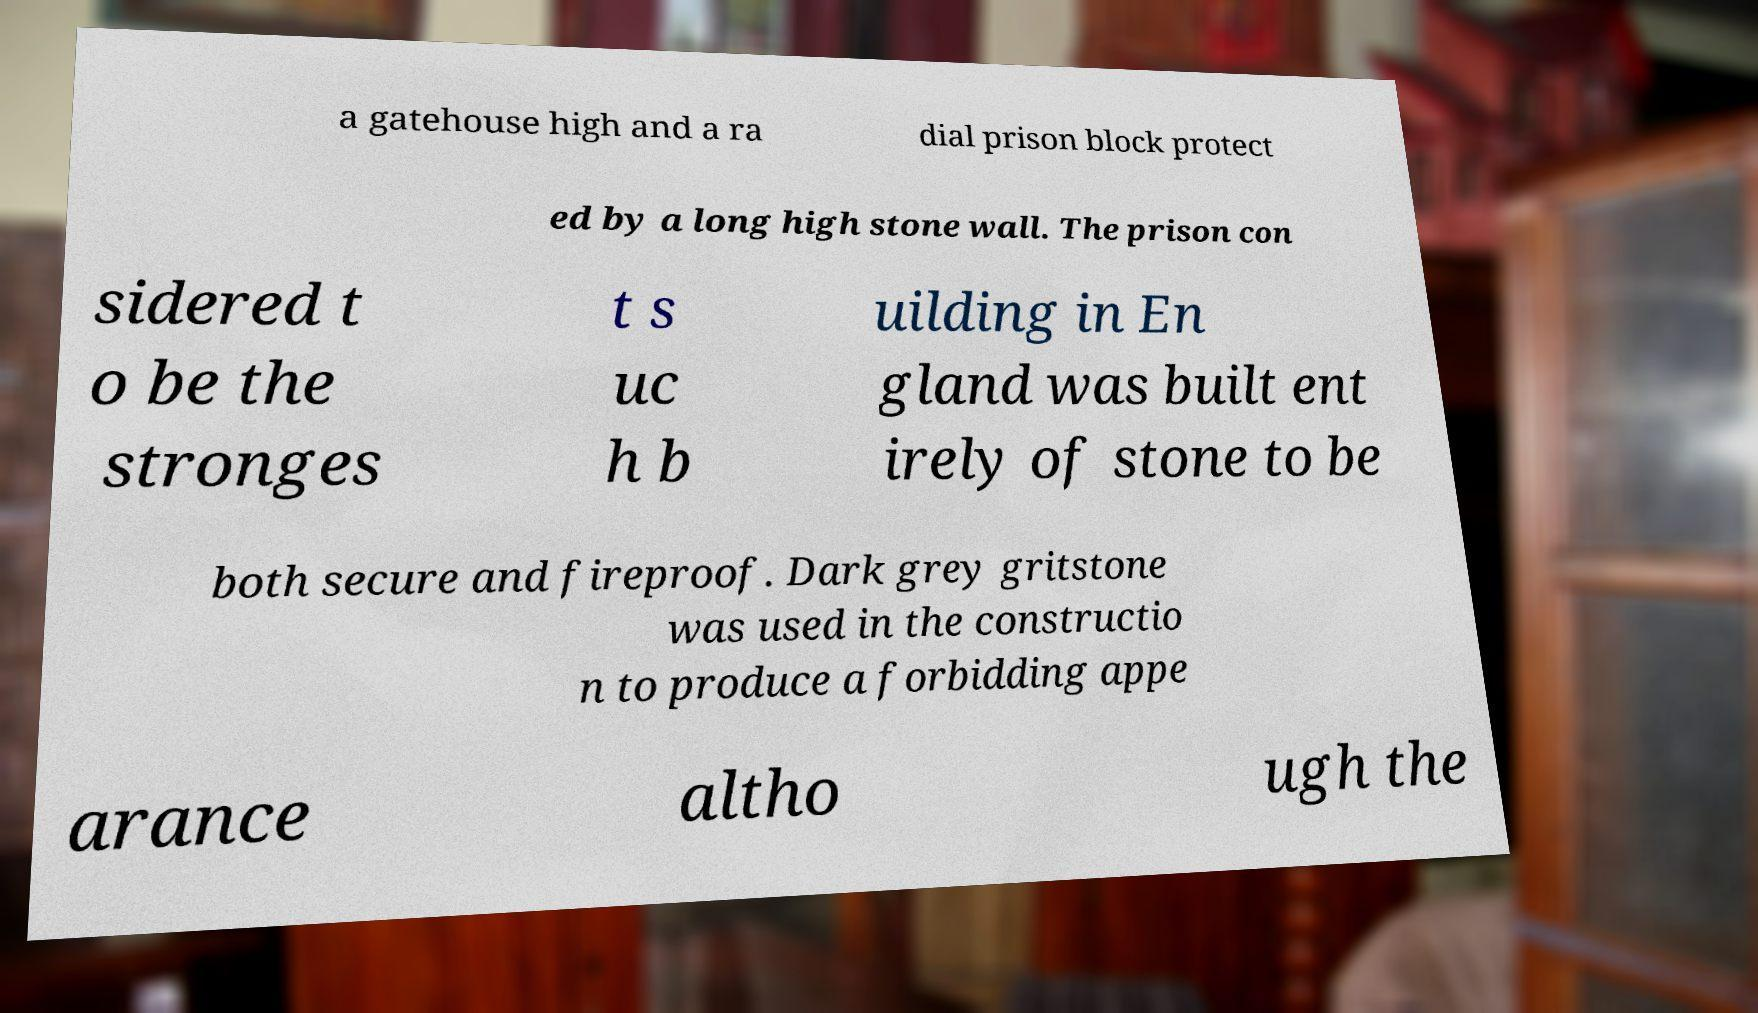Please identify and transcribe the text found in this image. a gatehouse high and a ra dial prison block protect ed by a long high stone wall. The prison con sidered t o be the stronges t s uc h b uilding in En gland was built ent irely of stone to be both secure and fireproof. Dark grey gritstone was used in the constructio n to produce a forbidding appe arance altho ugh the 